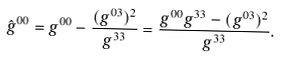Convert formula to latex. <formula><loc_0><loc_0><loc_500><loc_500>\hat { g } ^ { 0 0 } = g ^ { 0 0 } - \frac { ( g ^ { 0 3 } ) ^ { 2 } } { g ^ { 3 3 } } = \frac { g ^ { 0 0 } g ^ { 3 3 } - ( g ^ { 0 3 } ) ^ { 2 } } { g ^ { 3 3 } } .</formula> 